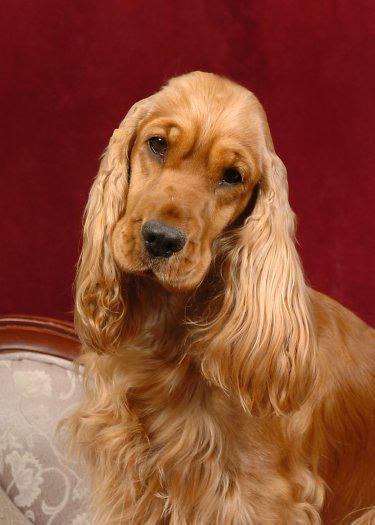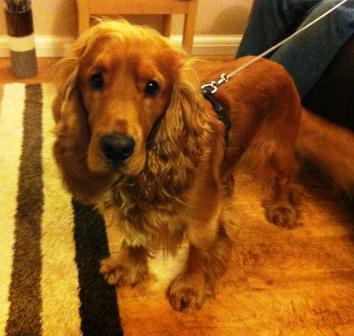The first image is the image on the left, the second image is the image on the right. Assess this claim about the two images: "A spaniel dog is chewing on some object in one of the images.". Correct or not? Answer yes or no. No. 